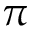<formula> <loc_0><loc_0><loc_500><loc_500>\pi</formula> 